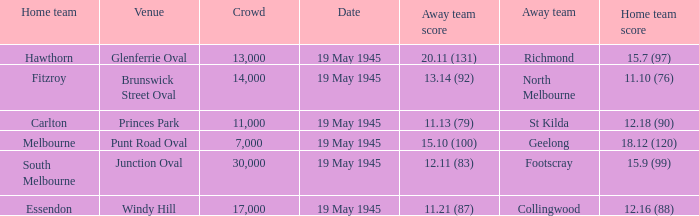On which date was Essendon the home team? 19 May 1945. 